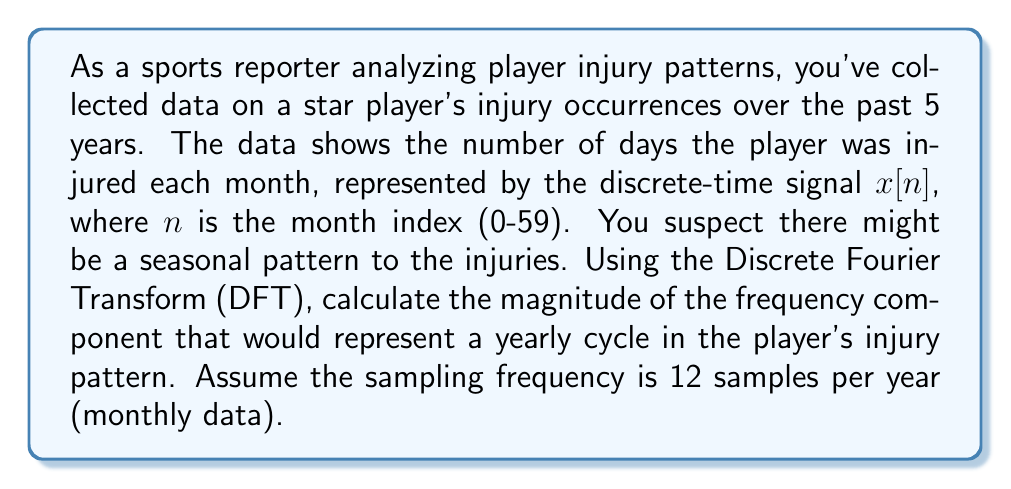Can you answer this question? To solve this problem, we need to follow these steps:

1) First, let's identify the frequency of a yearly cycle in our signal. Since we have monthly data (12 samples per year), a yearly cycle would complete one period every 12 samples.

2) The frequency of this yearly cycle in terms of cycles per sample is:
   $$f = \frac{1}{12} \text{ cycles/sample}$$

3) In the DFT, this frequency corresponds to the k-th bin, where:
   $$k = f \cdot N$$
   Here, N is the total number of samples (60 months = 5 years).

4) Calculating k:
   $$k = \frac{1}{12} \cdot 60 = 5$$

5) The DFT of the signal is given by:
   $$X[k] = \sum_{n=0}^{N-1} x[n] \cdot e^{-j2\pi kn/N}$$

6) The magnitude of this component is:
   $$|X[5]| = \left|\sum_{n=0}^{59} x[n] \cdot e^{-j2\pi 5n/60}\right|$$

7) Without the actual values of $x[n]$, we can't compute the exact magnitude. However, a large magnitude at this frequency would indicate a strong yearly pattern in the player's injuries.

8) For interpretation: If $|X[5]|$ is significantly larger than other frequency components, it suggests a yearly cycle in the player's injury pattern, which could be due to factors like the playing season structure or annual training regimens.
Answer: The magnitude of the yearly cycle frequency component is $|X[5]| = \left|\sum_{n=0}^{59} x[n] \cdot e^{-j2\pi 5n/60}\right|$, where $x[n]$ represents the number of injury days in month $n$. 